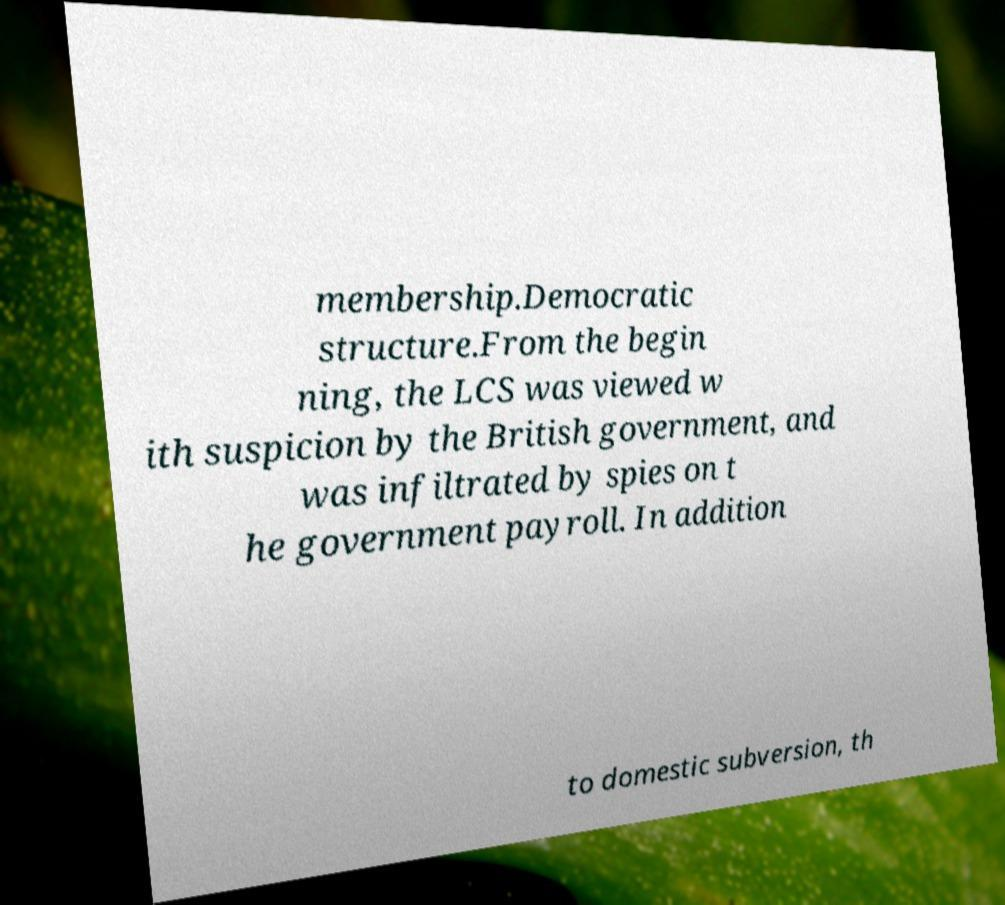I need the written content from this picture converted into text. Can you do that? membership.Democratic structure.From the begin ning, the LCS was viewed w ith suspicion by the British government, and was infiltrated by spies on t he government payroll. In addition to domestic subversion, th 